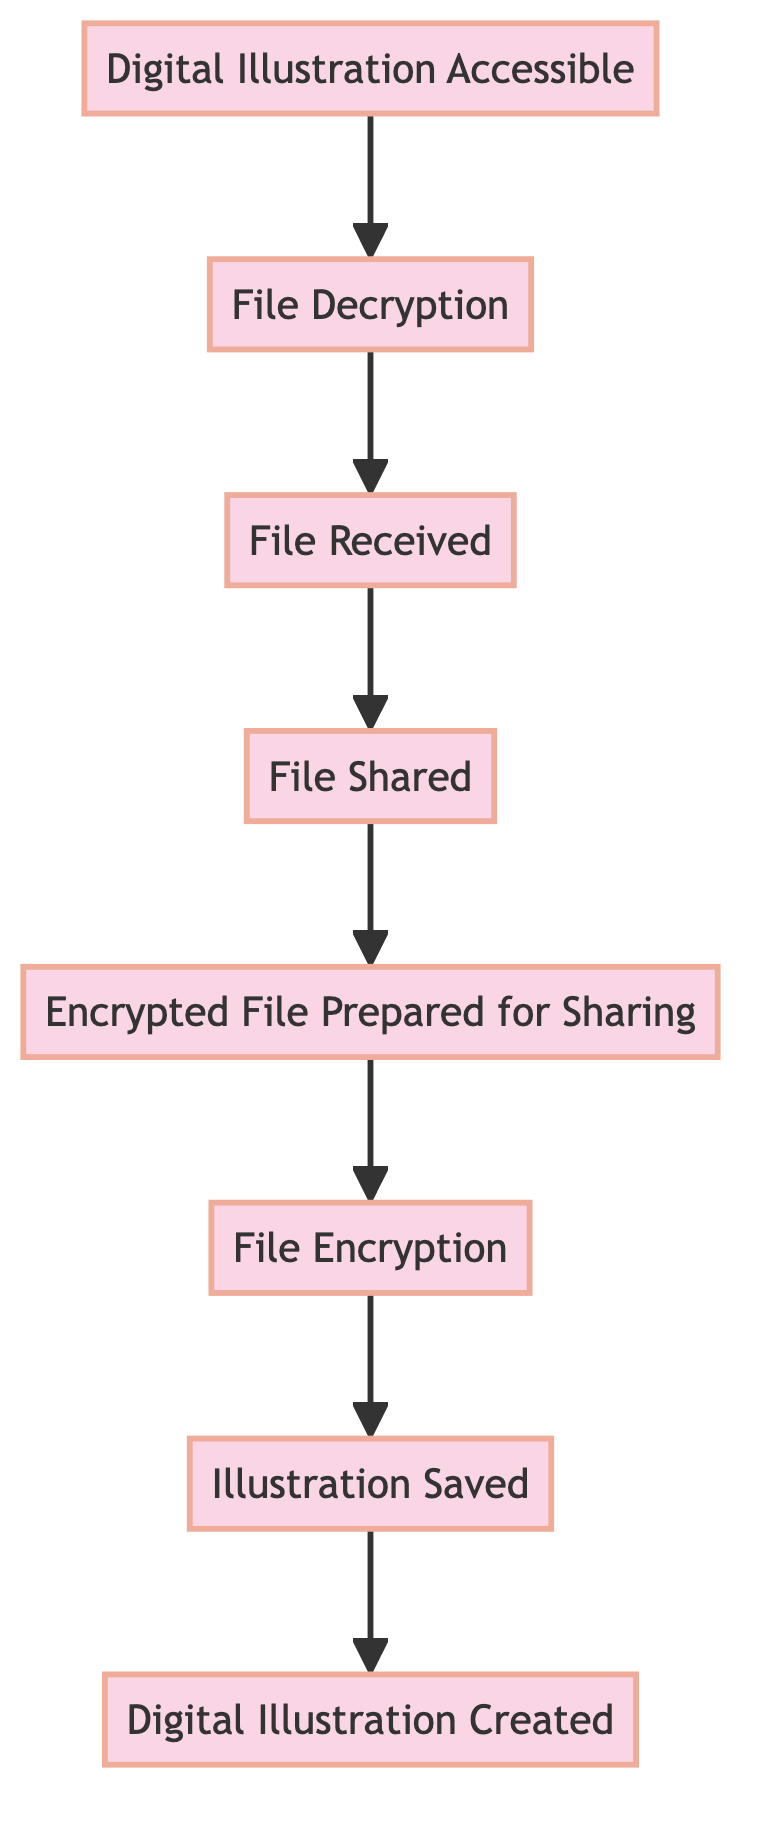What is the first step in the diagram? The diagram shows a flow from bottom to top, with the first step being at the lowest point, which is "Digital Illustration Created".
Answer: Digital Illustration Created How many steps are in the flowchart? By counting each individual process in the diagram, there are a total of eight steps that represent the flow from creation to accessibility of the digital illustration.
Answer: Eight What happens after the file is shared? The flowchart indicates that after the "File Shared" step, the next process is "File Received".
Answer: File Received Which process comes before file encryption? In the sequence of the flow, "Illustration Saved" is indicated as the immediate predecessor to "File Encryption".
Answer: Illustration Saved What is required for the recipient to access the digital illustration? According to the diagram, the recipient must perform "File Decryption" to access the digital illustration.
Answer: File Decryption How does the flowchart illustrate the sharing process? The flow is observed as moving upward through the nodes, where "File Shared" directly leads to "File Received", demonstrating the act of sharing leading to receipt.
Answer: File Shared to File Received What is the final outcome of this process flow? The end result of the flowchart is "Digital Illustration Accessible", which is the last step showing the final outcome after decryption.
Answer: Digital Illustration Accessible Which two steps are directly connected to file decryption? The steps that are directly connected to "File Decryption" in the flowchart are "File Received" and "Digital Illustration Accessible".
Answer: File Received and Digital Illustration Accessible 